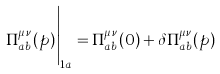<formula> <loc_0><loc_0><loc_500><loc_500>\Pi ^ { \mu \nu } _ { a b } ( p ) \Big | _ { 1 a } = \Pi ^ { \mu \nu } _ { a b } ( 0 ) + \delta \Pi ^ { \mu \nu } _ { a b } ( p )</formula> 